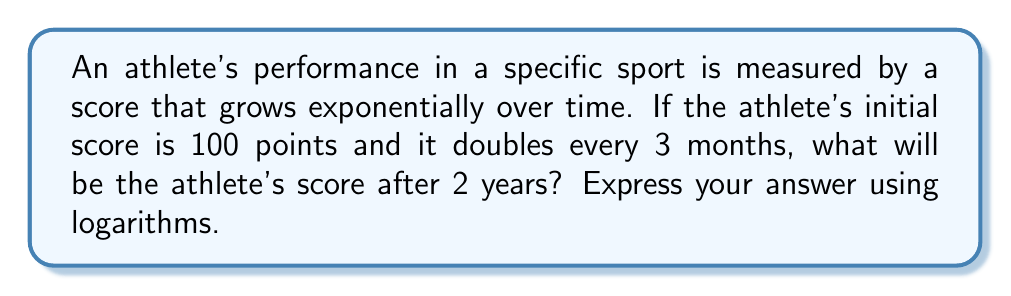Can you answer this question? Let's approach this step-by-step:

1) First, we need to identify the key information:
   - Initial score: 100 points
   - Doubles every 3 months
   - Time period: 2 years

2) We can express this as an exponential function:
   $$ S(t) = 100 \cdot 2^{\frac{t}{3}} $$
   Where $S(t)$ is the score at time $t$ (in months)

3) We need to find $S(24)$ since 2 years = 24 months

4) Let's substitute this into our equation:
   $$ S(24) = 100 \cdot 2^{\frac{24}{3}} = 100 \cdot 2^8 $$

5) Now, we can use the properties of logarithms to simplify this:
   $$ S(24) = 100 \cdot 2^8 = 100 \cdot 2^{2^3} $$

6) Using the power property of logarithms:
   $$ \log_2(S(24)) = \log_2(100) + 2^3 $$

7) Simplify:
   $$ \log_2(S(24)) = \log_2(100) + 8 $$

Therefore, the athlete's score after 2 years can be expressed as:
$$ S(24) = 2^{\log_2(100) + 8} $$
Answer: $2^{\log_2(100) + 8}$ 